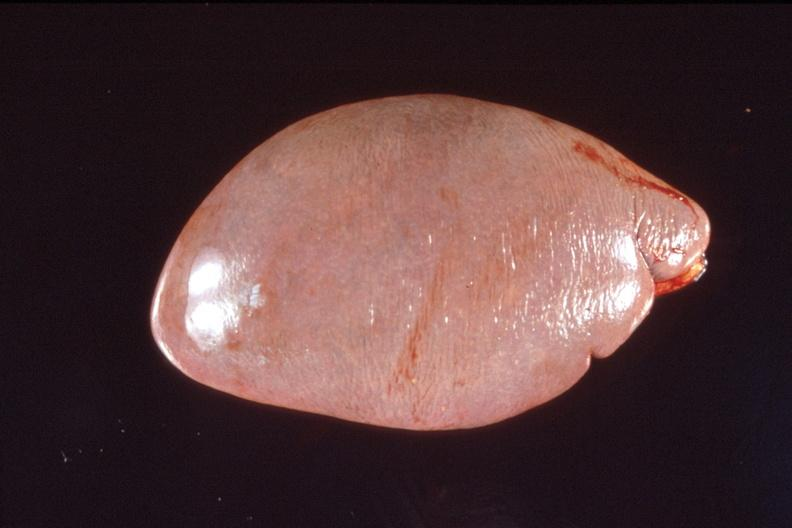s iron present?
Answer the question using a single word or phrase. No 